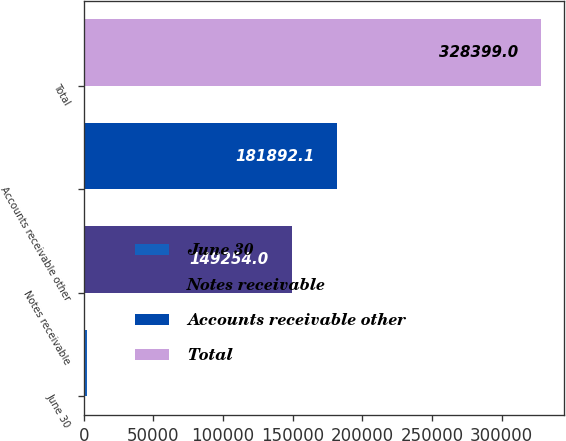Convert chart. <chart><loc_0><loc_0><loc_500><loc_500><bar_chart><fcel>June 30<fcel>Notes receivable<fcel>Accounts receivable other<fcel>Total<nl><fcel>2018<fcel>149254<fcel>181892<fcel>328399<nl></chart> 